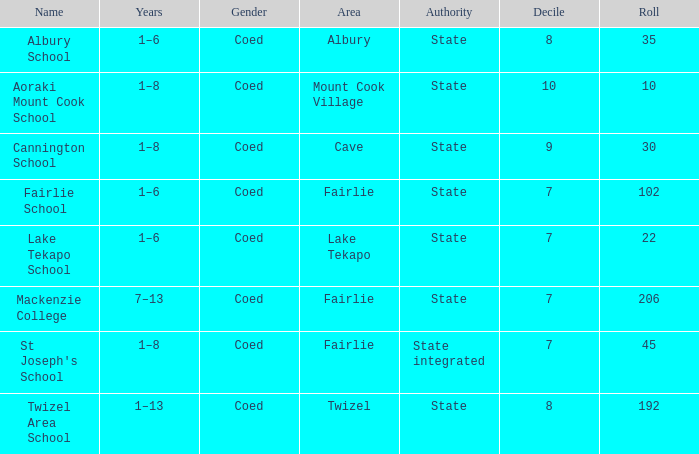What locality is known as mackenzie college? Fairlie. 